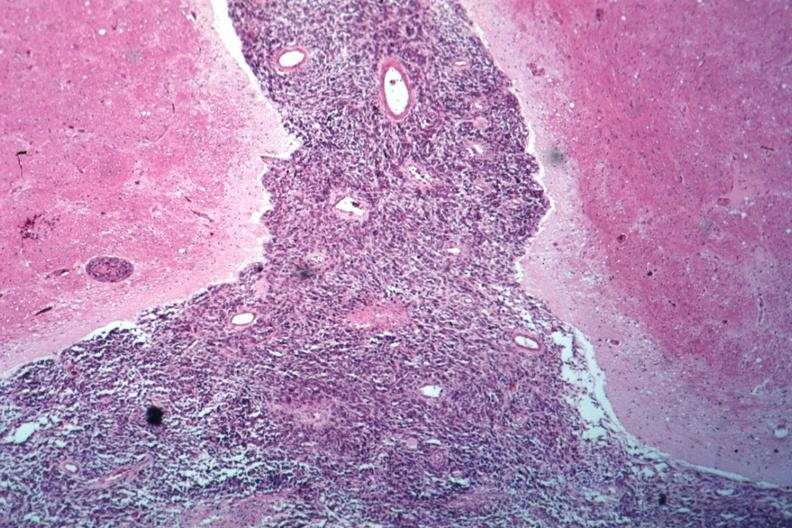s stein leventhal present?
Answer the question using a single word or phrase. No 